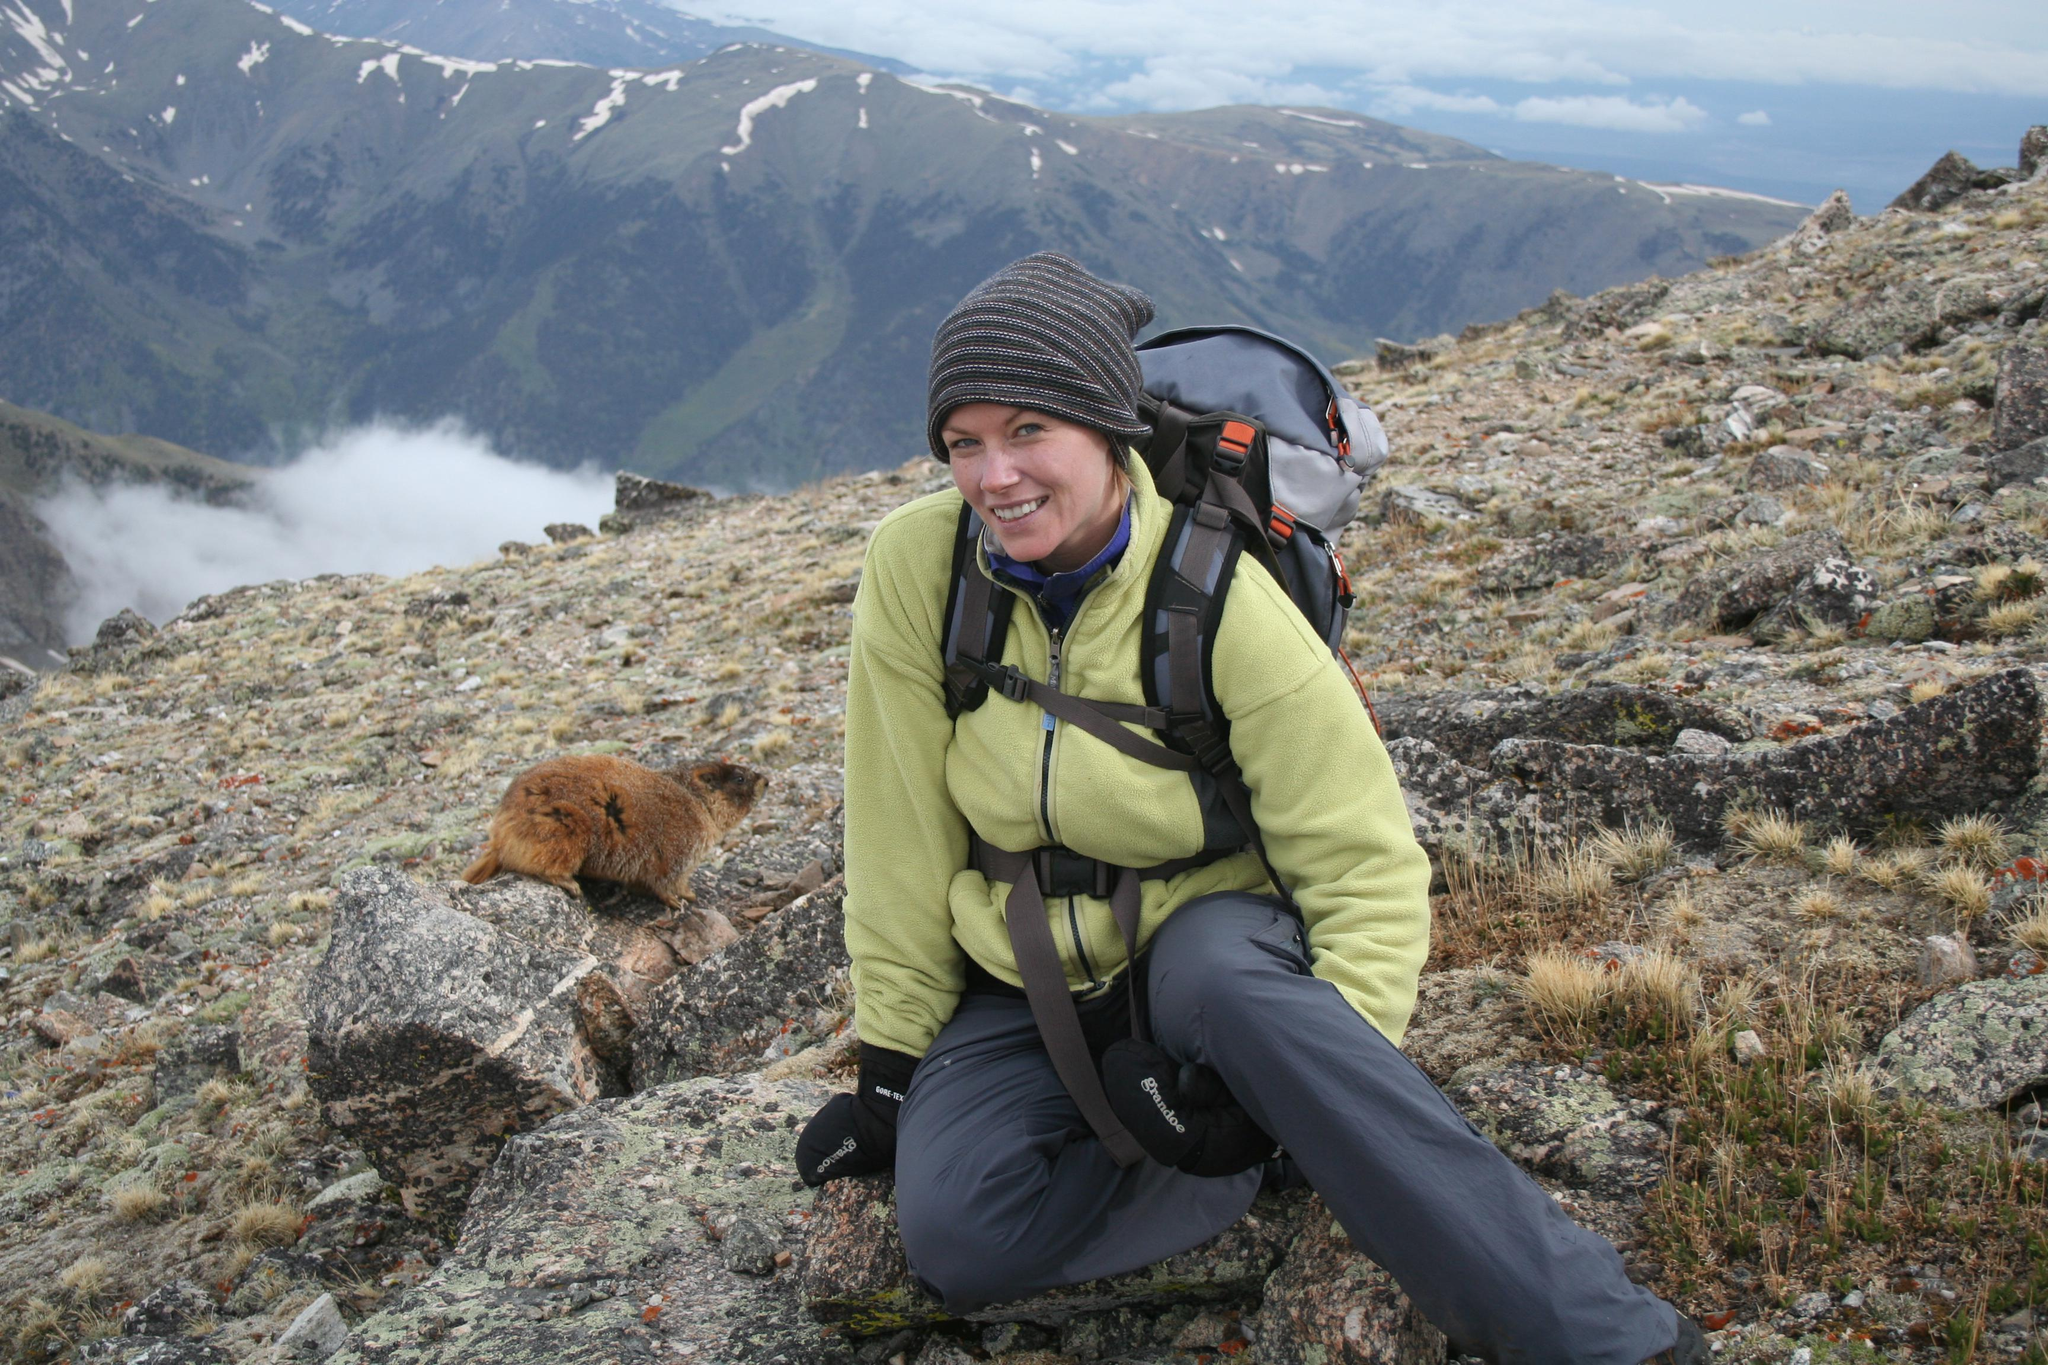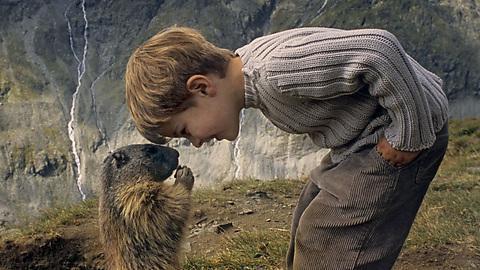The first image is the image on the left, the second image is the image on the right. Evaluate the accuracy of this statement regarding the images: "An image features an upright marmot with something clasped in its paws at mouth-level.". Is it true? Answer yes or no. Yes. The first image is the image on the left, the second image is the image on the right. Assess this claim about the two images: "The animal in the image on  the right is standing on its hind legs.". Correct or not? Answer yes or no. Yes. 